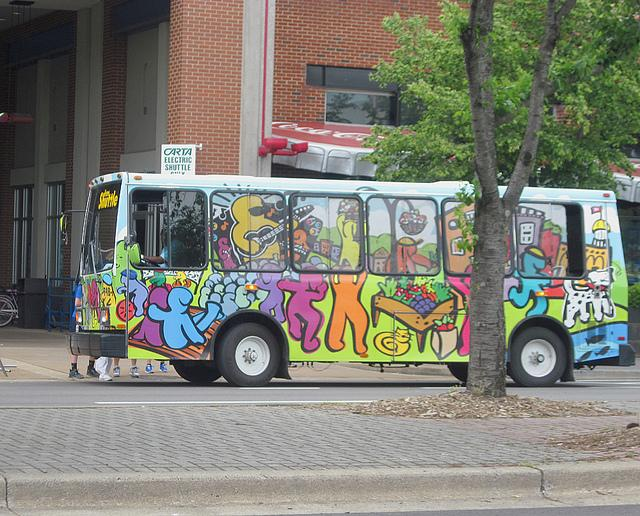What is the profession of the man seen on the bus?

Choices:
A) officer
B) doctor
C) judge
D) driver driver 